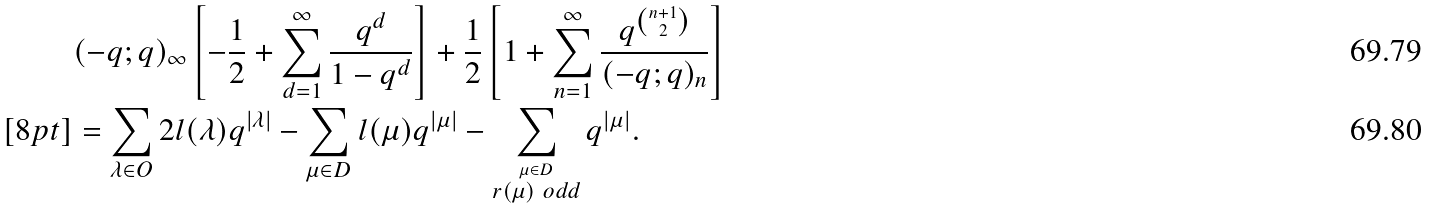Convert formula to latex. <formula><loc_0><loc_0><loc_500><loc_500>& ( - q ; q ) _ { \infty } \left [ - \frac { 1 } { 2 } + \sum _ { d = 1 } ^ { \infty } \frac { q ^ { d } } { 1 - q ^ { d } } \right ] + \frac { 1 } { 2 } \left [ 1 + \sum _ { n = 1 } ^ { \infty } \frac { q ^ { n + 1 \choose 2 } } { ( - q ; q ) _ { n } } \right ] \\ [ 8 p t ] & = \sum _ { \lambda \in O } 2 l ( \lambda ) q ^ { | \lambda | } - \sum _ { \mu \in D } l ( \mu ) q ^ { | \mu | } - \sum _ { \stackrel { \mu \in D } { r ( \mu ) \ o d d } } q ^ { | \mu | } .</formula> 